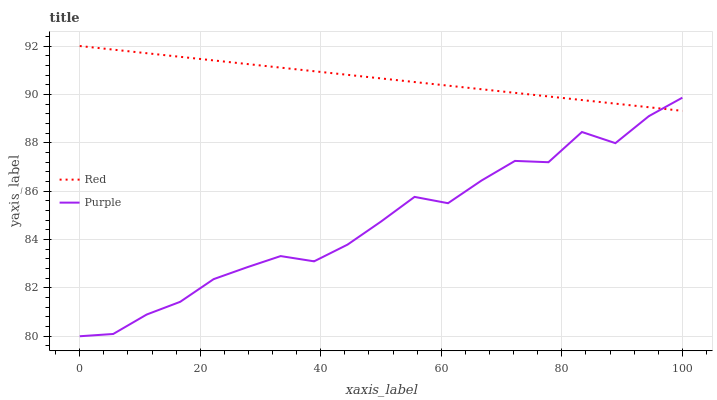Does Purple have the minimum area under the curve?
Answer yes or no. Yes. Does Red have the maximum area under the curve?
Answer yes or no. Yes. Does Red have the minimum area under the curve?
Answer yes or no. No. Is Red the smoothest?
Answer yes or no. Yes. Is Purple the roughest?
Answer yes or no. Yes. Is Red the roughest?
Answer yes or no. No. Does Purple have the lowest value?
Answer yes or no. Yes. Does Red have the lowest value?
Answer yes or no. No. Does Red have the highest value?
Answer yes or no. Yes. Does Red intersect Purple?
Answer yes or no. Yes. Is Red less than Purple?
Answer yes or no. No. Is Red greater than Purple?
Answer yes or no. No. 